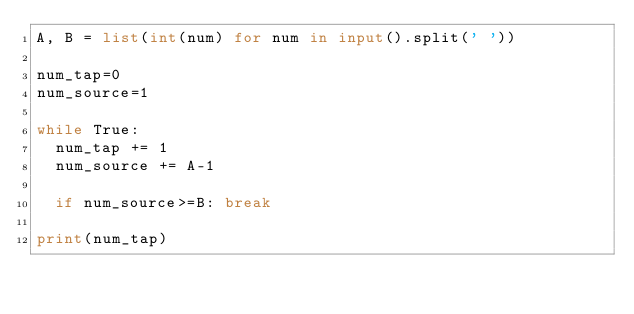<code> <loc_0><loc_0><loc_500><loc_500><_Python_>A, B = list(int(num) for num in input().split(' '))

num_tap=0
num_source=1

while True:
  num_tap += 1
  num_source += A-1 
  
  if num_source>=B: break
    
print(num_tap)</code> 